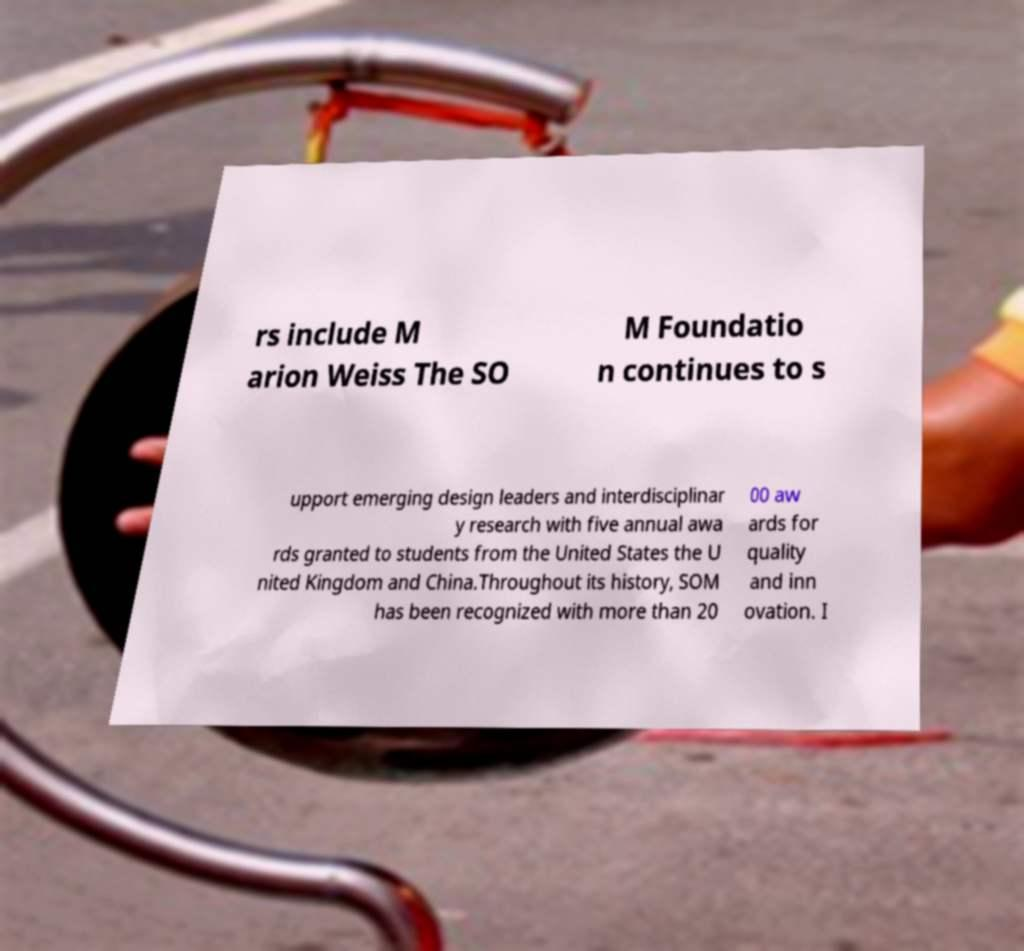Can you read and provide the text displayed in the image?This photo seems to have some interesting text. Can you extract and type it out for me? rs include M arion Weiss The SO M Foundatio n continues to s upport emerging design leaders and interdisciplinar y research with five annual awa rds granted to students from the United States the U nited Kingdom and China.Throughout its history, SOM has been recognized with more than 20 00 aw ards for quality and inn ovation. I 